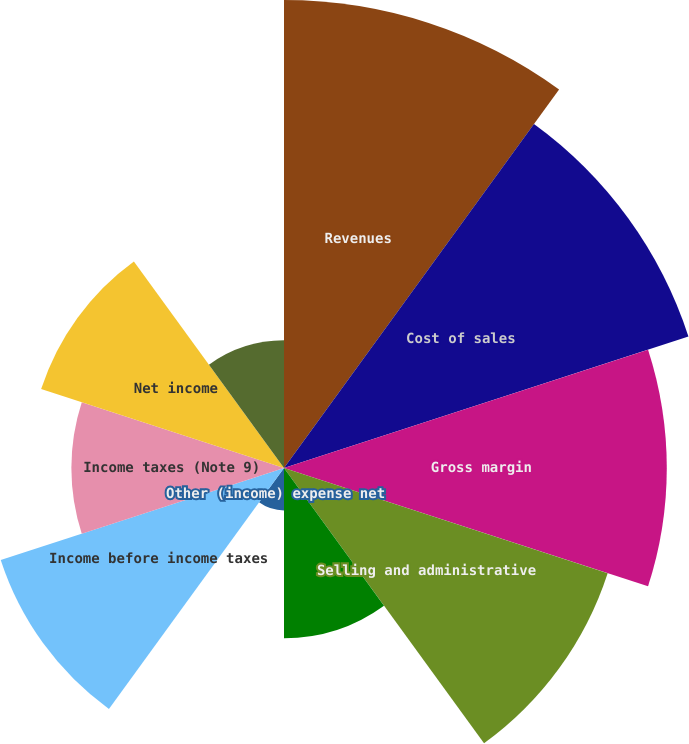<chart> <loc_0><loc_0><loc_500><loc_500><pie_chart><fcel>Revenues<fcel>Cost of sales<fcel>Gross margin<fcel>Selling and administrative<fcel>Interest income net (Notes 1 7<fcel>Other (income) expense net<fcel>Income before income taxes<fcel>Income taxes (Note 9)<fcel>Net income<fcel>Basic earnings per common<nl><fcel>17.19%<fcel>15.62%<fcel>14.06%<fcel>12.5%<fcel>6.25%<fcel>1.56%<fcel>10.94%<fcel>7.81%<fcel>9.38%<fcel>4.69%<nl></chart> 